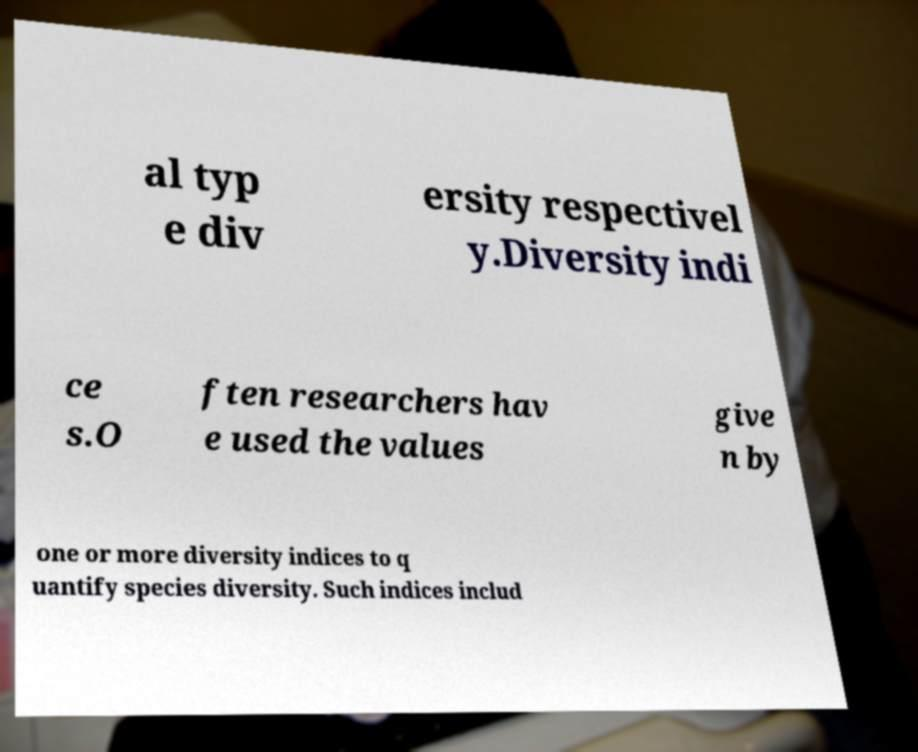There's text embedded in this image that I need extracted. Can you transcribe it verbatim? al typ e div ersity respectivel y.Diversity indi ce s.O ften researchers hav e used the values give n by one or more diversity indices to q uantify species diversity. Such indices includ 